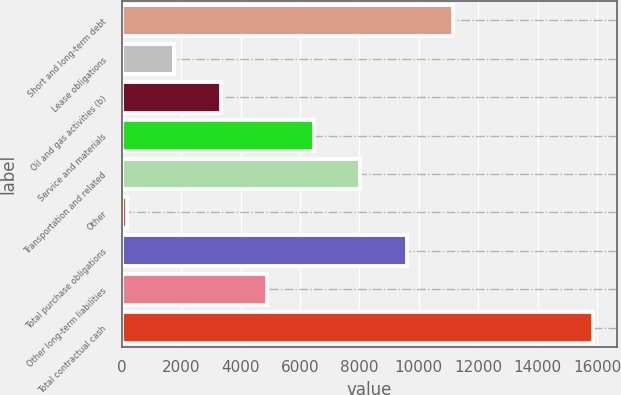Convert chart to OTSL. <chart><loc_0><loc_0><loc_500><loc_500><bar_chart><fcel>Short and long-term debt<fcel>Lease obligations<fcel>Oil and gas activities (b)<fcel>Service and materials<fcel>Transportation and related<fcel>Other<fcel>Total purchase obligations<fcel>Other long-term liabilities<fcel>Total contractual cash<nl><fcel>11158.9<fcel>1758.7<fcel>3325.4<fcel>6458.8<fcel>8025.5<fcel>192<fcel>9592.2<fcel>4892.1<fcel>15859<nl></chart> 